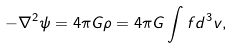<formula> <loc_0><loc_0><loc_500><loc_500>- \nabla ^ { 2 } \psi = 4 \pi G \rho = 4 \pi G \int f d ^ { 3 } { v } ,</formula> 